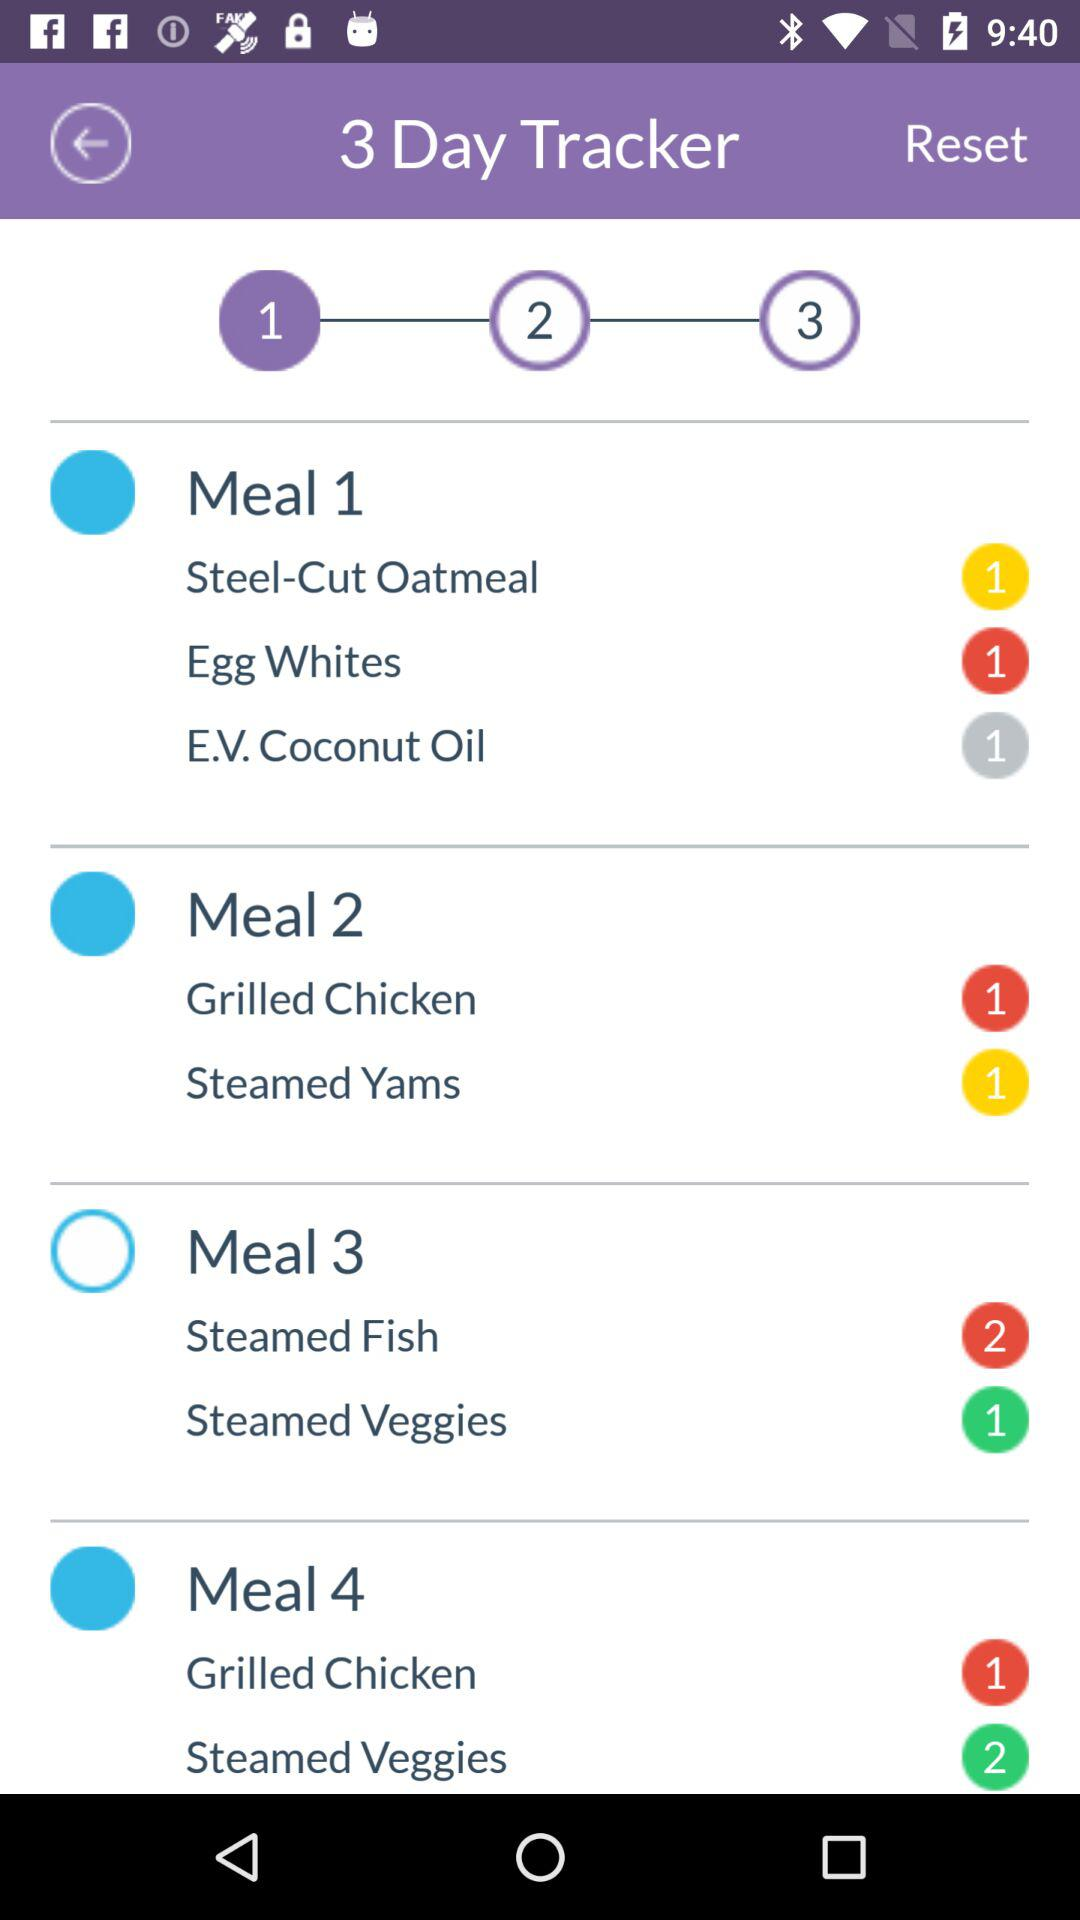How many days are there in the current tracker?
Answer the question using a single word or phrase. 3 